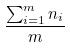<formula> <loc_0><loc_0><loc_500><loc_500>\frac { \sum _ { i = 1 } ^ { m } n _ { i } } { m }</formula> 